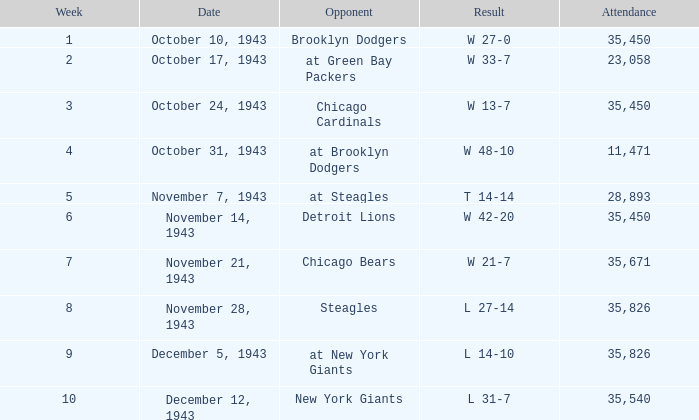How many attendances have w 48-10 as the result? 11471.0. 